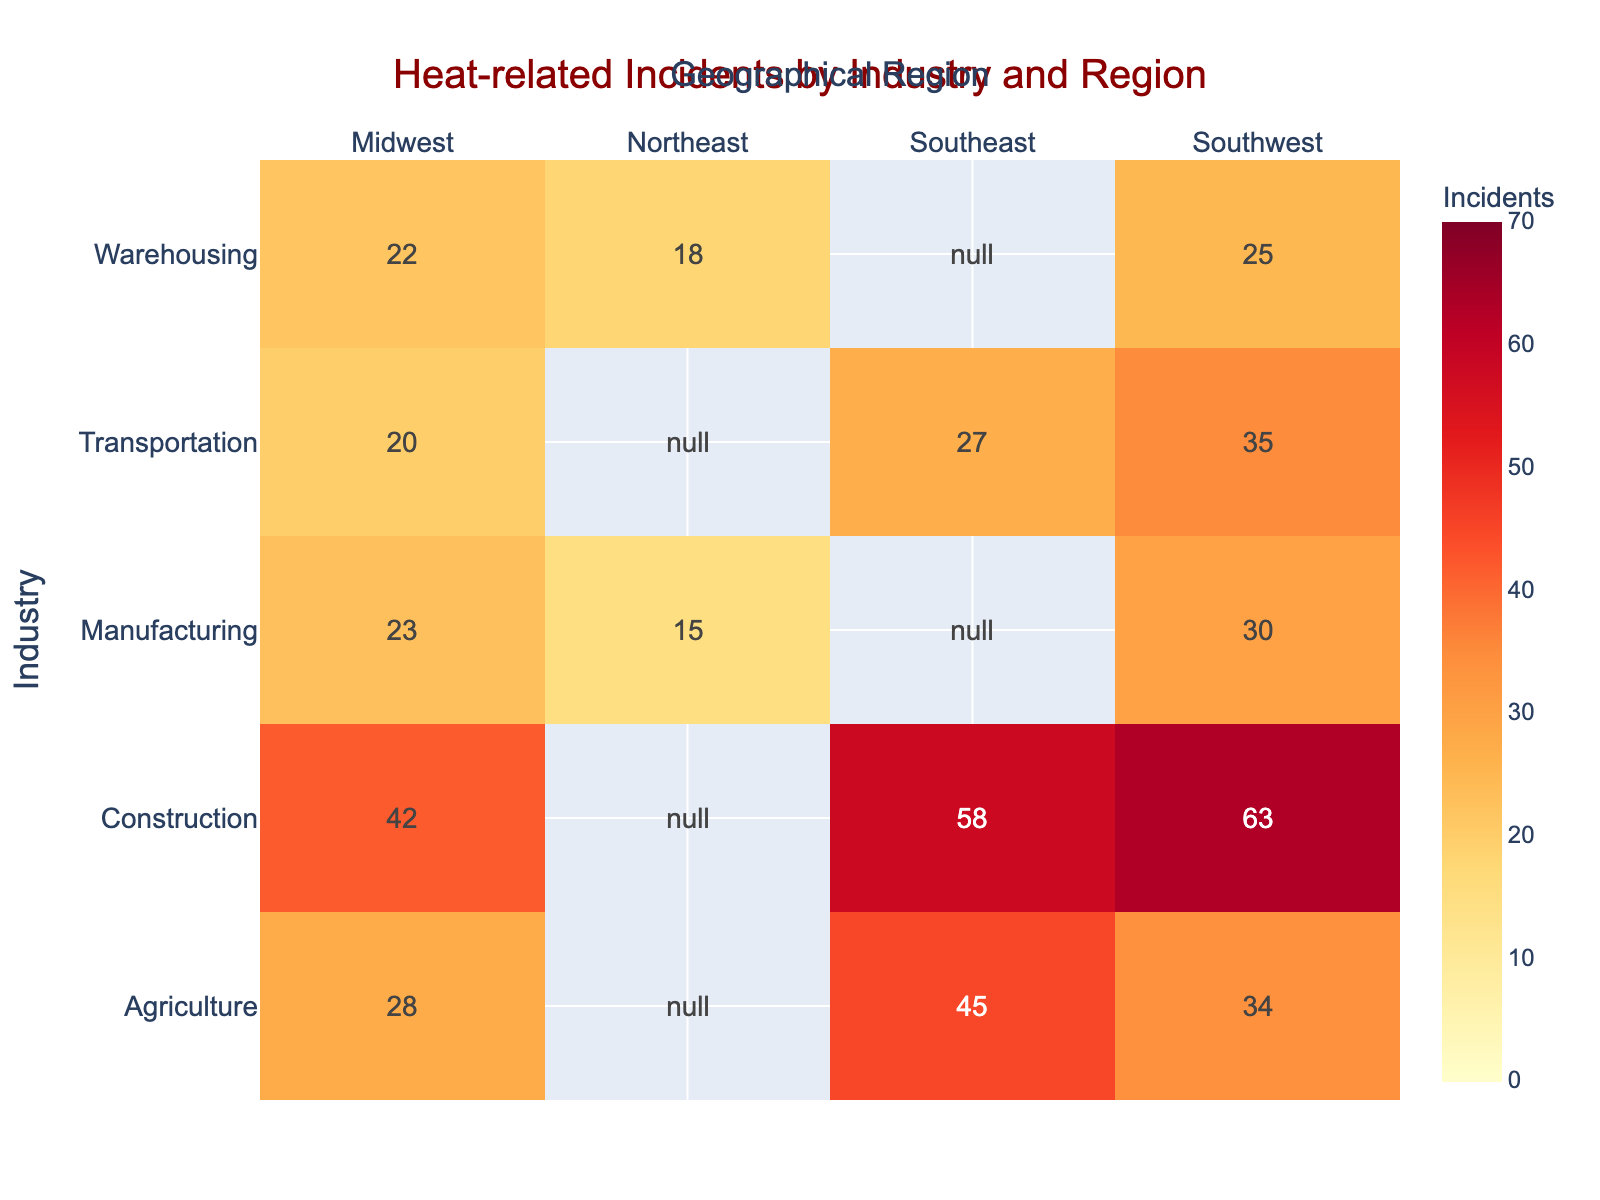What is the title of the heatmap? The title of the heatmap is prominently displayed at the top of the figure. By reading the text in that position, we can see that the title is "Heat-related Incidents by Industry and Region."
Answer: Heat-related Incidents by Industry and Region Which industry has the highest number of heat-related incidents in the Southeast region? By looking at the intersection of the Industry "Construction" and the Geographical Region "Southeast," we can see the highest value. The incident count in this cell is 58.
Answer: Construction What is the total number of heat-related incidents in the Southwest region across all industries? Add the number of incidents for all industries in the Southwest: Agriculture (34), Construction (63), Manufacturing (30), Transportation (35), and Warehousing (25). Hence, 34 + 63 + 30 + 35 + 25 = 187.
Answer: 187 Which region has the fewest heat-related incidents in the Manufacturing industry? Look at the row for Manufacturing and identify the cell with the lowest value. The values are Northeast (15), Midwest (23), and Southwest (30). The lowest value is 15 in the Northeast region.
Answer: Northeast Compare the number of heat-related incidents in the Agriculture industry between the Southeast and Midwest regions. Which one has more, and what is the difference? Southeast has 45 incidents, and Midwest has 28 incidents. To find the difference, subtract the Midwest's value from the Southeast's. Hence, 45 - 28 = 17. The Southeast has more incidents.
Answer: Southeast, 17 What is the combined total of heat-related incidents in the Midwest region for the Construction and Transportation industries? Add the values for Construction (42) and Transportation (20) in the Midwest region: 42 + 20 = 62.
Answer: 62 Which industry experiences the most heat-related incidents in the Southwest? Compare the numbers in the Southwest column: Agriculture (34), Construction (63), Manufacturing (30), Transportation (35), and Warehousing (25). Construction has the highest number with 63 incidents.
Answer: Construction Is there any industry that shows the same number of heat-related incidents across different regions? Check the values for each industry to see if there are repeated numbers across different regions. No industry has the same number across different regions in the dataset provided.
Answer: No 